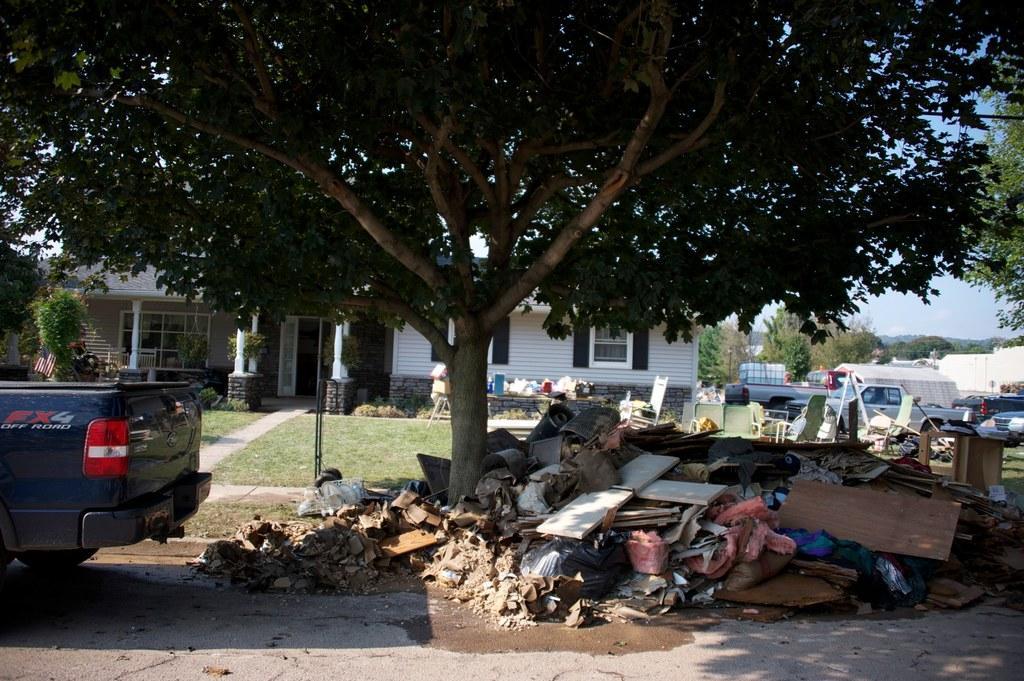In one or two sentences, can you explain what this image depicts? In this picture we can see wooden planks, clothes, vehicles, grass, chair, trees, building with windows, some objects and in the background we can see the sky. 